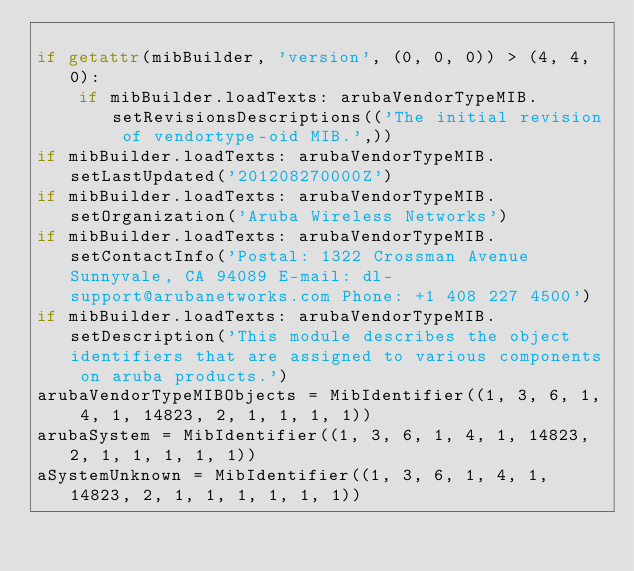<code> <loc_0><loc_0><loc_500><loc_500><_Python_>
if getattr(mibBuilder, 'version', (0, 0, 0)) > (4, 4, 0):
    if mibBuilder.loadTexts: arubaVendorTypeMIB.setRevisionsDescriptions(('The initial revision of vendortype-oid MIB.',))
if mibBuilder.loadTexts: arubaVendorTypeMIB.setLastUpdated('201208270000Z')
if mibBuilder.loadTexts: arubaVendorTypeMIB.setOrganization('Aruba Wireless Networks')
if mibBuilder.loadTexts: arubaVendorTypeMIB.setContactInfo('Postal: 1322 Crossman Avenue Sunnyvale, CA 94089 E-mail: dl-support@arubanetworks.com Phone: +1 408 227 4500')
if mibBuilder.loadTexts: arubaVendorTypeMIB.setDescription('This module describes the object identifiers that are assigned to various components on aruba products.')
arubaVendorTypeMIBObjects = MibIdentifier((1, 3, 6, 1, 4, 1, 14823, 2, 1, 1, 1, 1))
arubaSystem = MibIdentifier((1, 3, 6, 1, 4, 1, 14823, 2, 1, 1, 1, 1, 1))
aSystemUnknown = MibIdentifier((1, 3, 6, 1, 4, 1, 14823, 2, 1, 1, 1, 1, 1, 1))</code> 